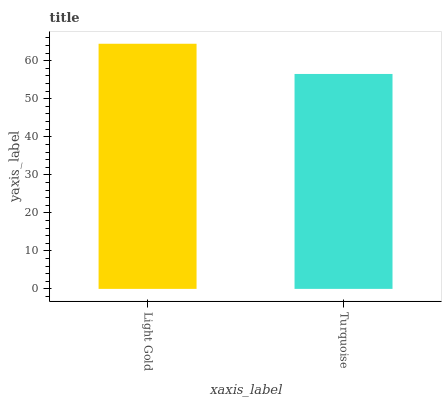Is Turquoise the maximum?
Answer yes or no. No. Is Light Gold greater than Turquoise?
Answer yes or no. Yes. Is Turquoise less than Light Gold?
Answer yes or no. Yes. Is Turquoise greater than Light Gold?
Answer yes or no. No. Is Light Gold less than Turquoise?
Answer yes or no. No. Is Light Gold the high median?
Answer yes or no. Yes. Is Turquoise the low median?
Answer yes or no. Yes. Is Turquoise the high median?
Answer yes or no. No. Is Light Gold the low median?
Answer yes or no. No. 